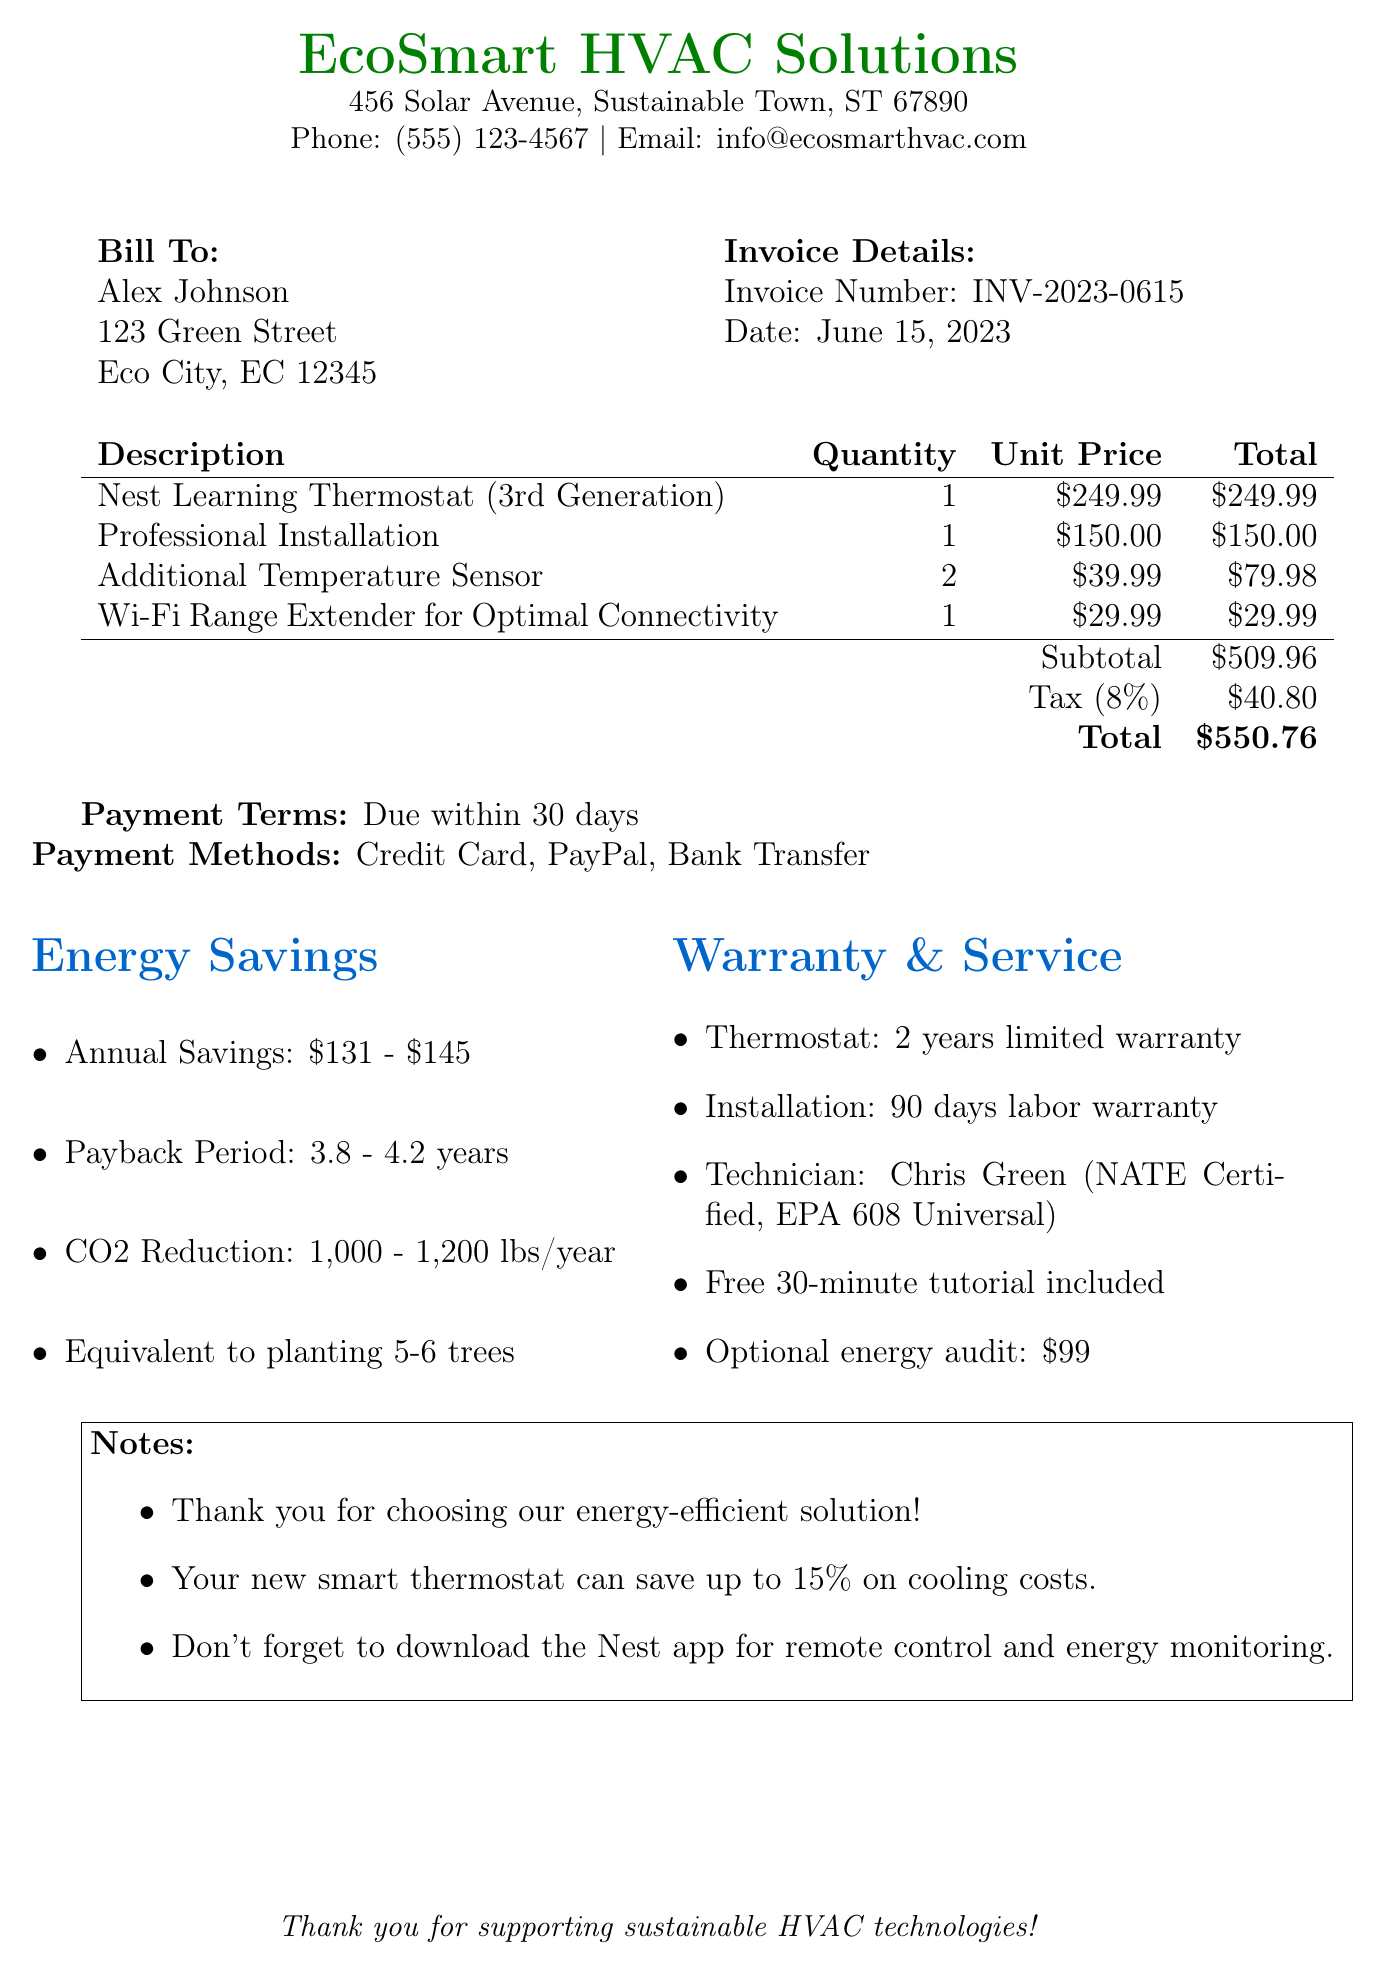What is the invoice number? The invoice number is a specific reference assigned to the transaction, which is found in the document details.
Answer: INV-2023-0615 Who is the customer? The customer is identified in the "Bill To" section of the document, which provides their name and address.
Answer: Alex Johnson What is the date of the invoice? The date is a specific point in time when the invoice was issued, mentioned in the document.
Answer: June 15, 2023 What is the total amount due? The total amount is the final amount payable, summing the subtotal and tax, specified in the financial details.
Answer: $550.76 How many additional temperature sensors were included? The quantity of additional temperature sensors is stated under the itemized list of products sold.
Answer: 2 What is the estimated annual CO2 reduction? The document estimates the amount of CO2 that will not be emitted annually due to the energy-efficient system, located in the eco impact section.
Answer: 1,000 - 1,200 lbs What is the warranty period for the thermostat? The warranty details are outlined in the "Warranty & Service" section of the document, specifying coverage and duration.
Answer: 2 years limited manufacturer warranty What is the payback period for the investment? The payback period suggests how long it will take for the savings to equal the investment, found in the energy savings section.
Answer: 3.8 - 4.2 years What types of payment methods are accepted? The document specifies payment methods, which can be found in the payment terms section.
Answer: Credit Card, PayPal, Bank Transfer 